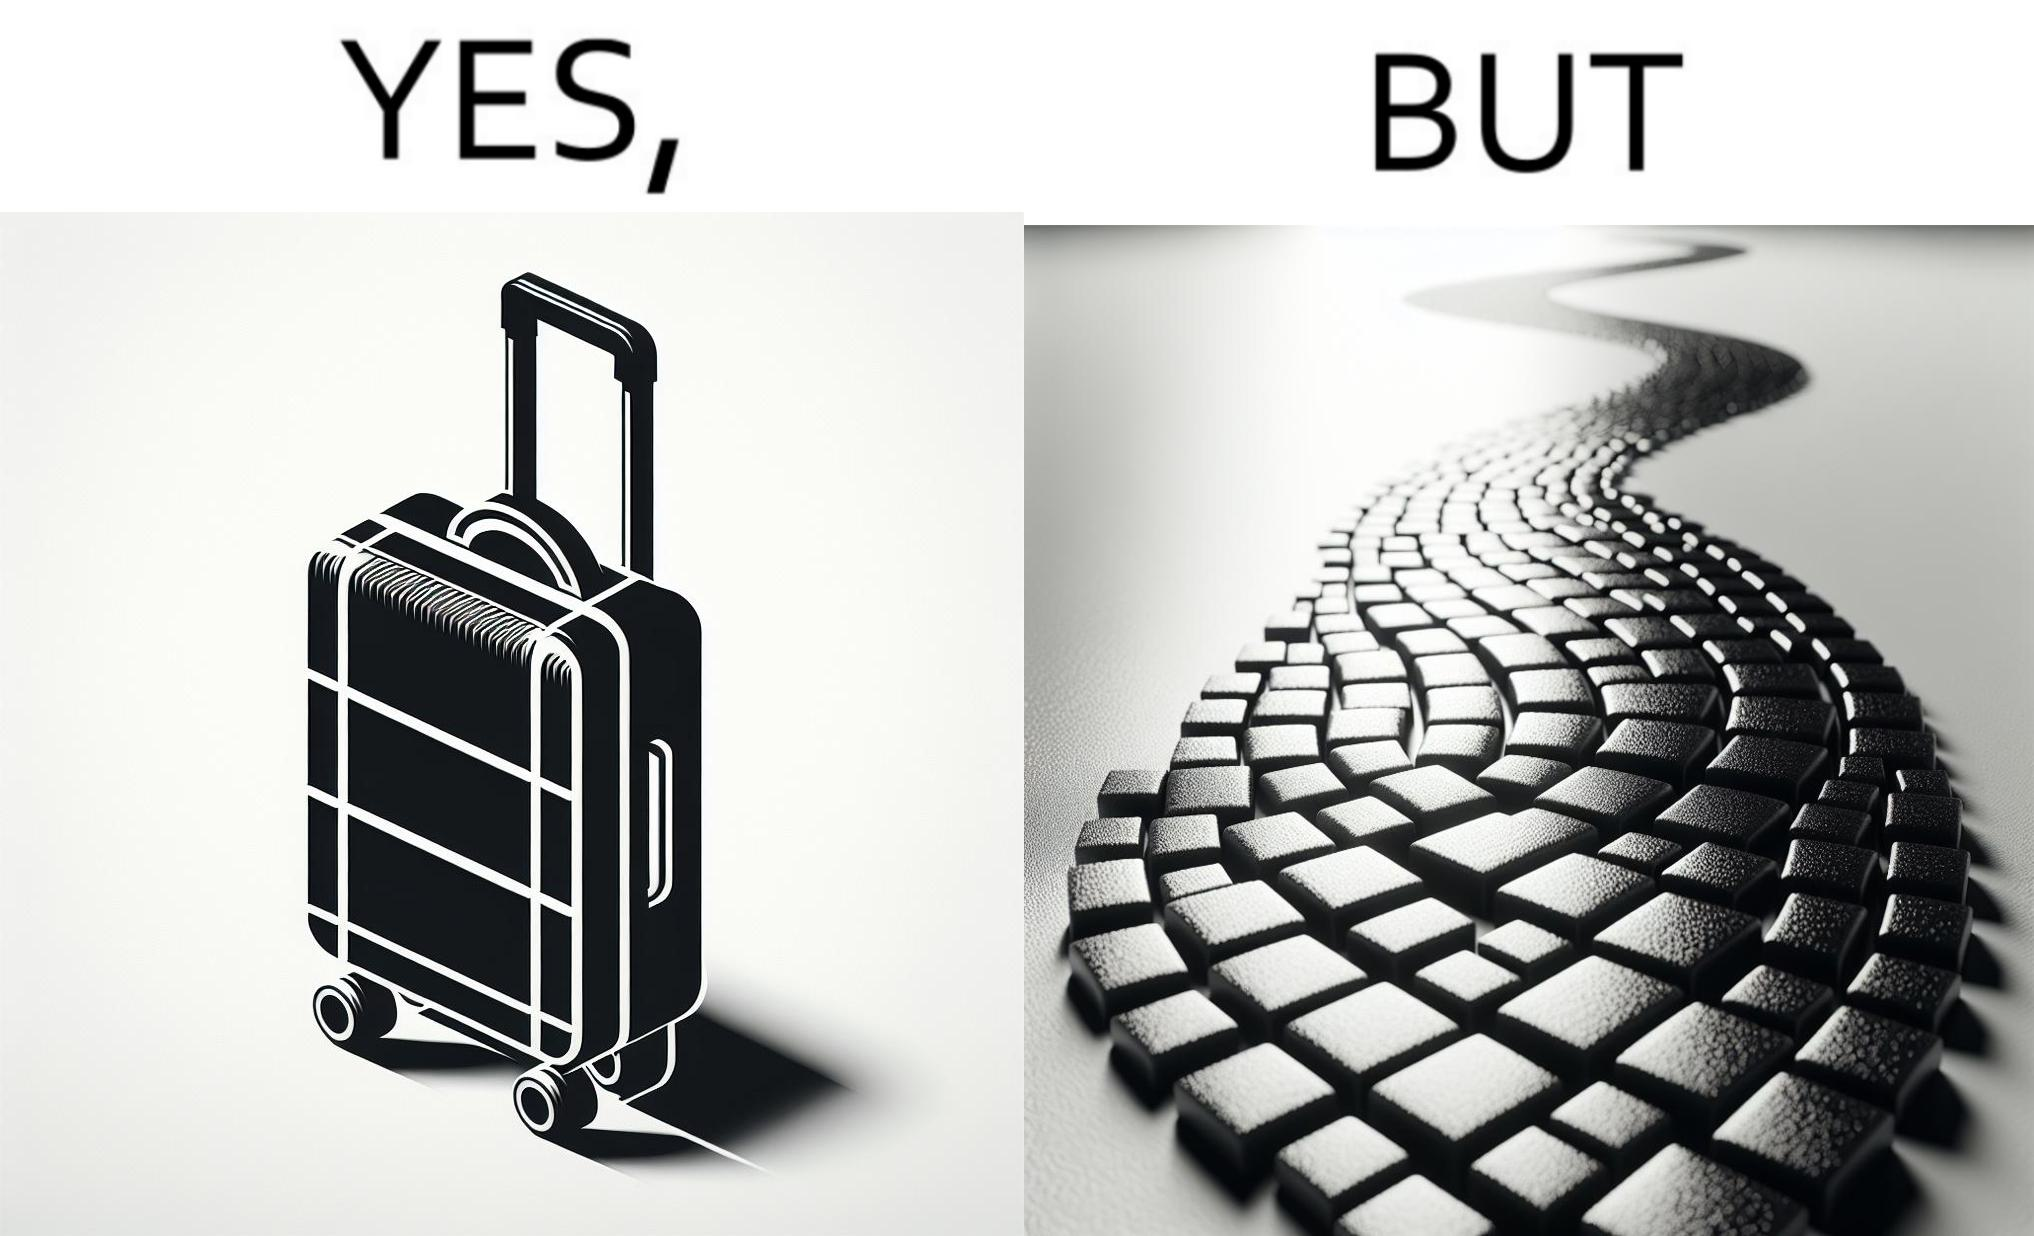What do you see in each half of this image? In the left part of the image: it is a trolley luggage bag In the right part of the image: It is a cobblestone road 